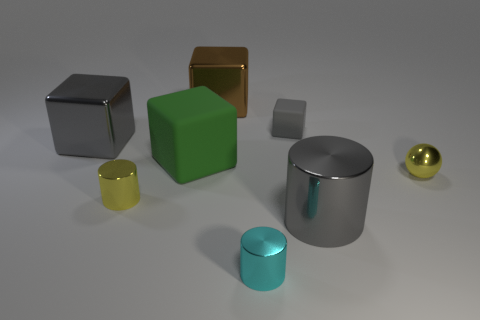Subtract all purple cylinders. Subtract all green balls. How many cylinders are left? 3 Add 1 tiny spheres. How many objects exist? 9 Subtract all balls. How many objects are left? 7 Subtract all big green cubes. Subtract all small spheres. How many objects are left? 6 Add 6 small yellow balls. How many small yellow balls are left? 7 Add 8 small yellow matte blocks. How many small yellow matte blocks exist? 8 Subtract 0 gray spheres. How many objects are left? 8 